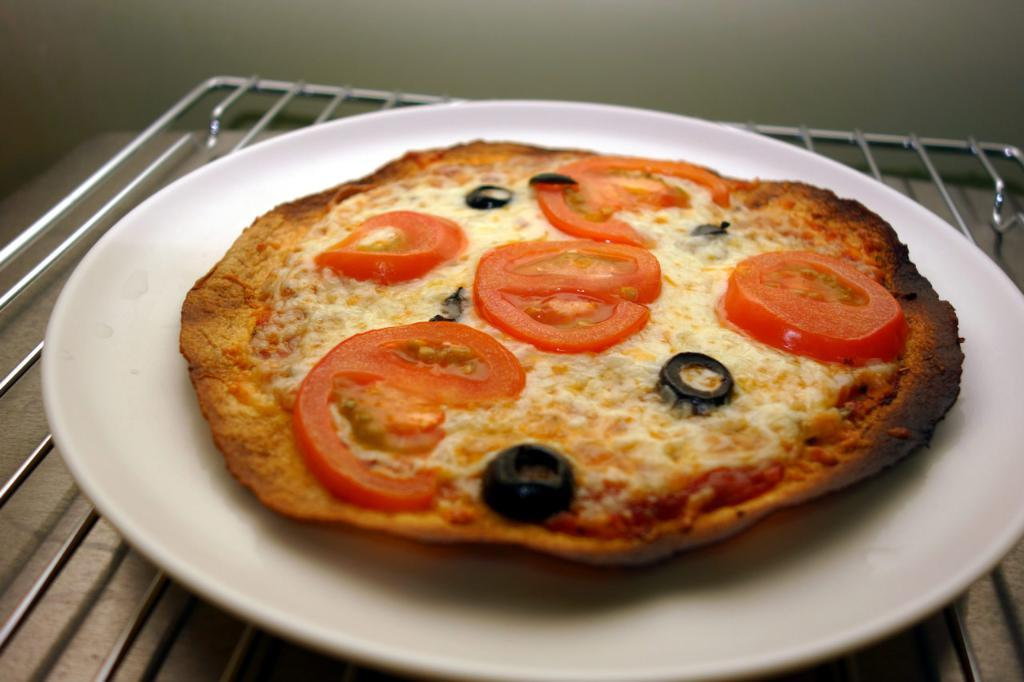What type of food is on the plate in the image? There is a pizza on a plate in the image. How is the plate positioned in the image? The plate is placed on a steel mesh. What is the steel mesh resting on? The steel mesh is placed on a table. What can be seen in the background of the image? There is a wall in the background of the image. What type of cart is visible in the image? There is no cart present in the image. Is there a locket hanging from the wall in the image? There is no locket visible in the image; only a wall can be seen in the background. 